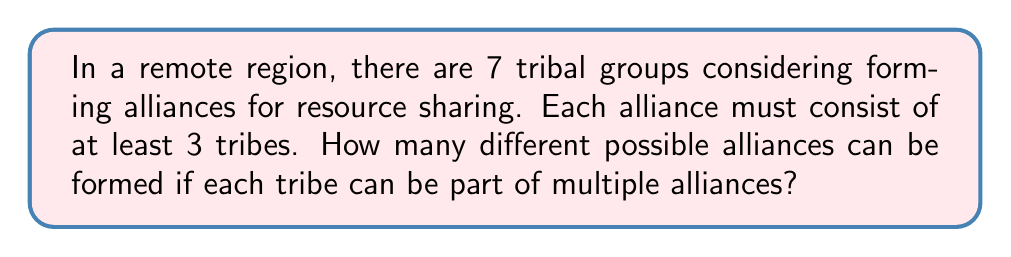Show me your answer to this math problem. Let's approach this step-by-step:

1) First, we need to understand that this is a combination problem. We're selecting groups of tribes from the total 7 tribes.

2) The alliances can be of size 3, 4, 5, 6, or 7 tribes.

3) For each size, we need to calculate the number of possible combinations:

   For 3 tribes: $\binom{7}{3}$
   For 4 tribes: $\binom{7}{4}$
   For 5 tribes: $\binom{7}{5}$
   For 6 tribes: $\binom{7}{6}$
   For 7 tribes: $\binom{7}{7}$

4) Let's calculate each of these:

   $\binom{7}{3} = \frac{7!}{3!(7-3)!} = \frac{7!}{3!4!} = 35$
   $\binom{7}{4} = \frac{7!}{4!(7-4)!} = \frac{7!}{4!3!} = 35$
   $\binom{7}{5} = \frac{7!}{5!(7-5)!} = \frac{7!}{5!2!} = 21$
   $\binom{7}{6} = \frac{7!}{6!(7-6)!} = \frac{7!}{6!1!} = 7$
   $\binom{7}{7} = \frac{7!}{7!(7-7)!} = \frac{7!}{7!0!} = 1$

5) The total number of possible alliances is the sum of all these combinations:

   $35 + 35 + 21 + 7 + 1 = 99$

Therefore, there are 99 different possible alliances that can be formed.
Answer: 99 